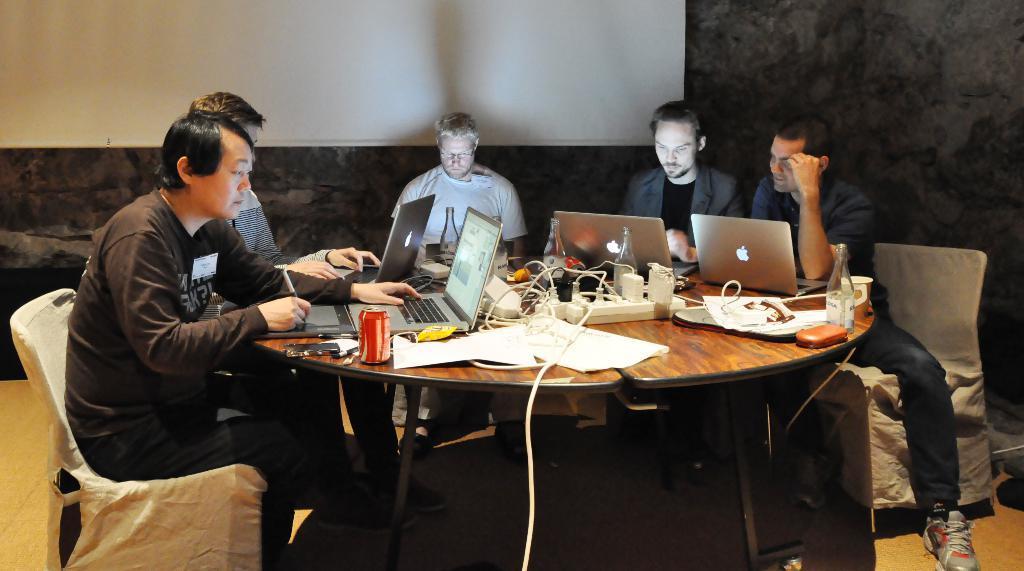Could you give a brief overview of what you see in this image? In this picture I can see there are five men sitting at the table and they have laptops in front of them and they have papers, cables, beverage can, beer bottles, smart phone and in the backdrop there is a screen and there is a wall. 